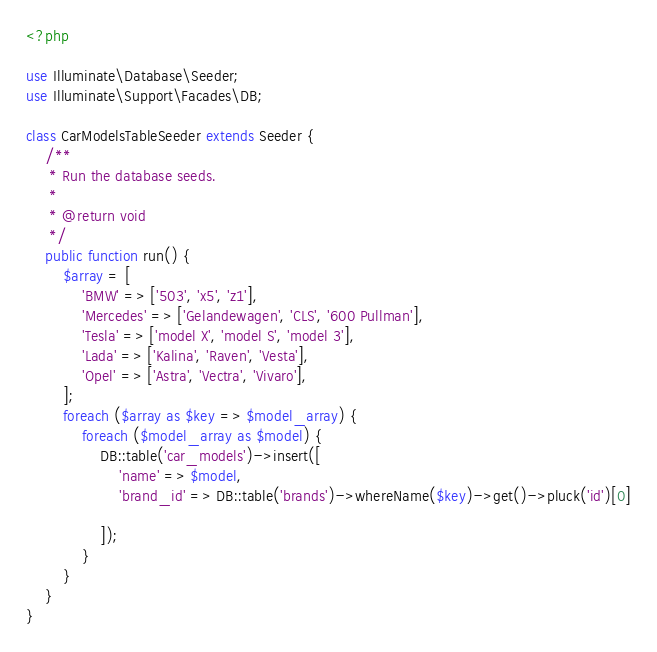Convert code to text. <code><loc_0><loc_0><loc_500><loc_500><_PHP_><?php

use Illuminate\Database\Seeder;
use Illuminate\Support\Facades\DB;

class CarModelsTableSeeder extends Seeder {
    /**
     * Run the database seeds.
     *
     * @return void
     */
    public function run() {
        $array = [
            'BMW' => ['503', 'x5', 'z1'],
            'Mercedes' => ['Gelandewagen', 'CLS', '600 Pullman'],
            'Tesla' => ['model X', 'model S', 'model 3'],
            'Lada' => ['Kalina', 'Raven', 'Vesta'],
            'Opel' => ['Astra', 'Vectra', 'Vivaro'],
        ];
        foreach ($array as $key => $model_array) {
            foreach ($model_array as $model) {
                DB::table('car_models')->insert([
                    'name' => $model,
                    'brand_id' => DB::table('brands')->whereName($key)->get()->pluck('id')[0]

                ]);
            }
        }
    }
}
</code> 